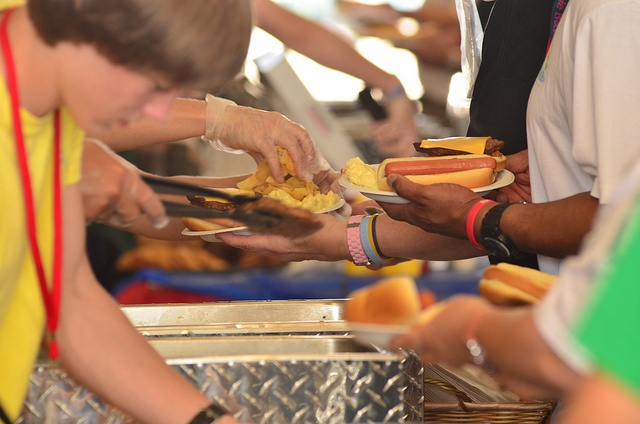Describe the objects in this image and their specific colors. I can see people in khaki, tan, brown, maroon, and gold tones, people in gold, tan, darkgray, and maroon tones, people in gold, salmon, tan, and brown tones, people in gold, salmon, tan, and brown tones, and people in khaki, maroon, and brown tones in this image. 